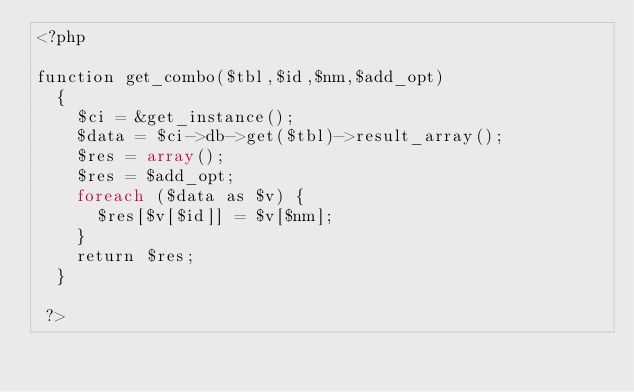<code> <loc_0><loc_0><loc_500><loc_500><_PHP_><?php 

function get_combo($tbl,$id,$nm,$add_opt)
	{
		$ci = &get_instance();
		$data = $ci->db->get($tbl)->result_array();
		$res = array();
		$res = $add_opt;
		foreach ($data as $v) {
			$res[$v[$id]] = $v[$nm];
		}
		return $res;
	}

 ?></code> 